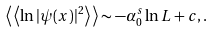<formula> <loc_0><loc_0><loc_500><loc_500>\left \langle \, \left \langle \ln | \psi ( x ) | ^ { 2 } \right \rangle \, \right \rangle \sim - \alpha _ { 0 } ^ { s } \ln L + c , .</formula> 